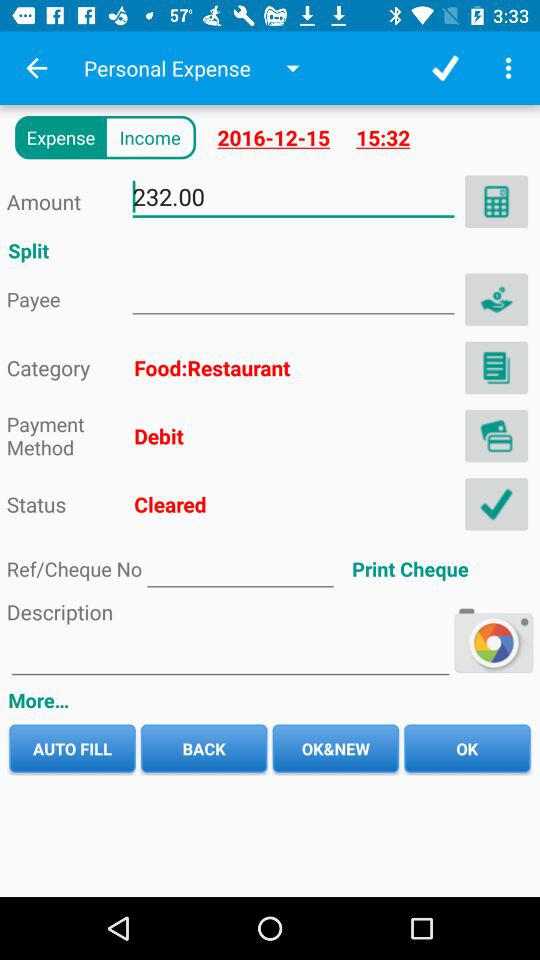What is the expense time? The expense time is 3:32 pm. 